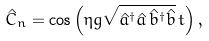Convert formula to latex. <formula><loc_0><loc_0><loc_500><loc_500>\hat { C } _ { n } = \cos \left ( \eta g \sqrt { \hat { a } ^ { \dagger } \hat { a } \, \hat { b } ^ { \dagger } \hat { b } } \, t \right ) ,</formula> 